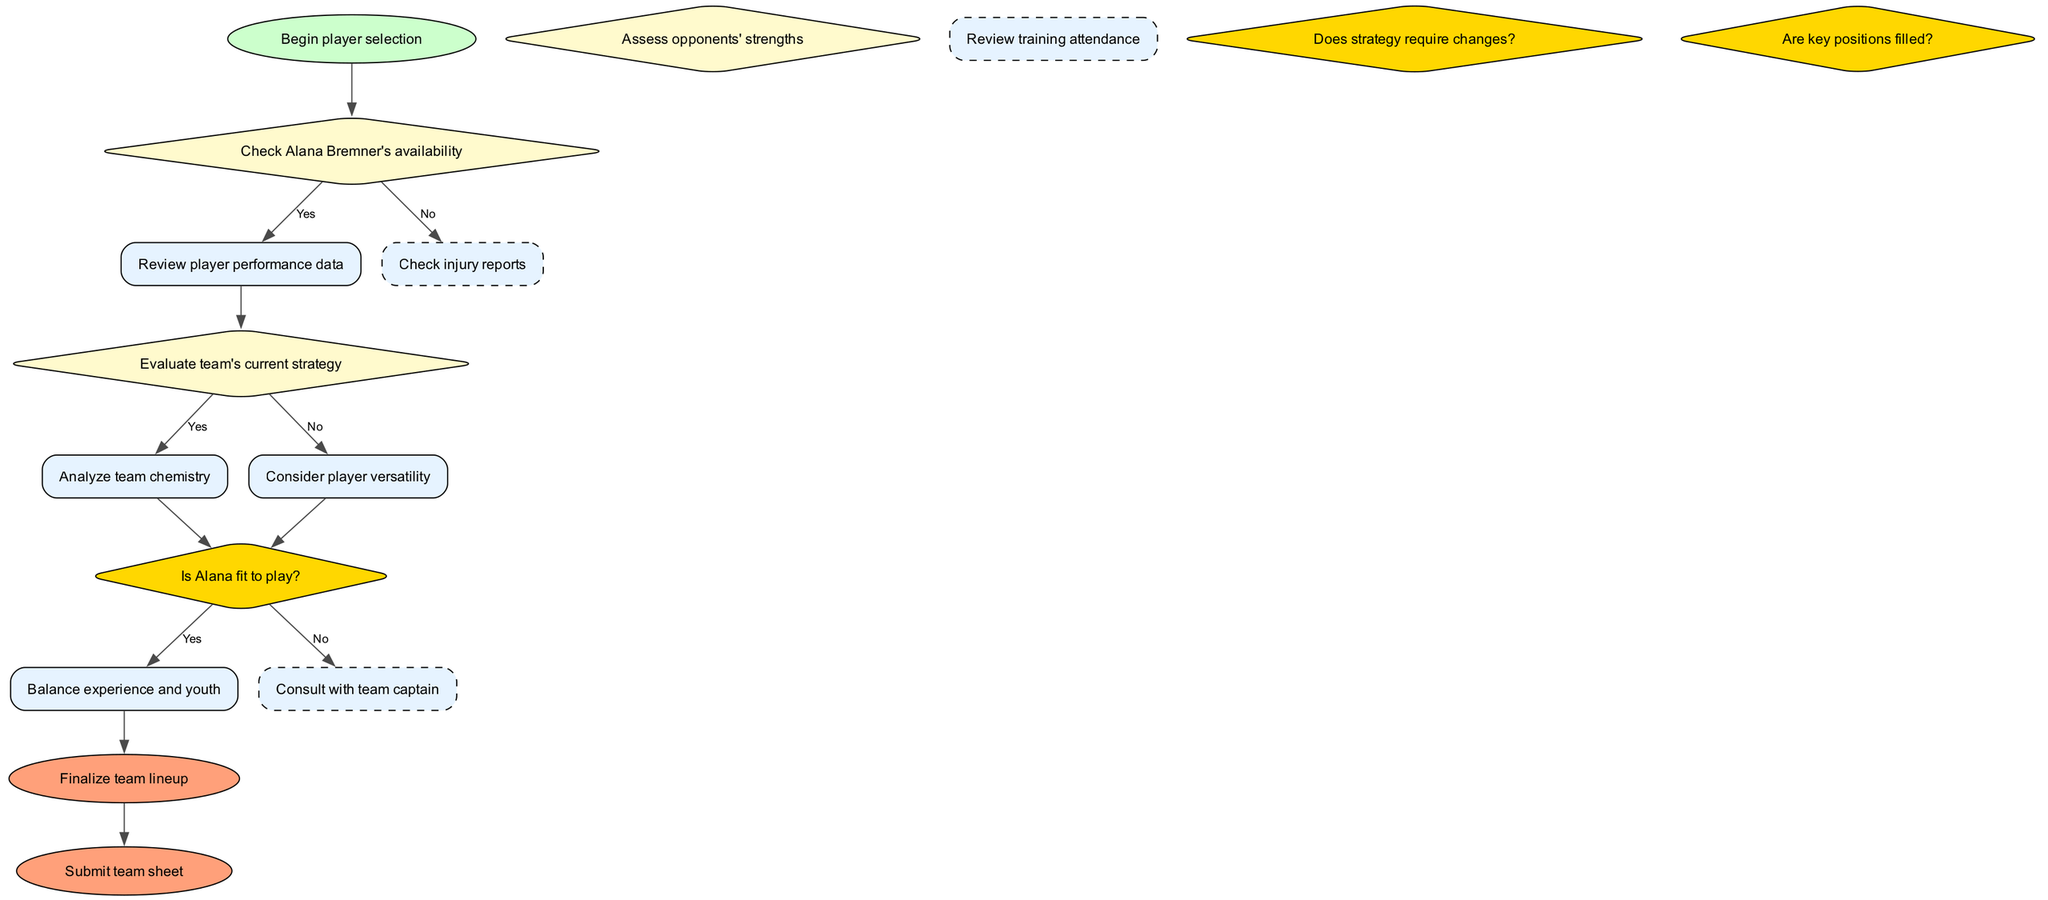What is the first step in the player selection algorithm? The first step is "Begin player selection," as indicated by the start node in the diagram.
Answer: Begin player selection How many decisions are made in the selection process? There are three decisions shown in the diagram, which are labeled sequentially as decision nodes.
Answer: 3 What happens if Alana Bremner is available? If Alana is available (fit to play), the flow proceeds to review player performance data, which is indicated by the edge labeled 'Yes' from the availability decision node.
Answer: Review player performance data If the strategy does not require changes, what is the subsequent action? If the strategy does not require changes, the flow directs toward considering player versatility, as indicated by the edge labeled 'No' from the strategy decision node.
Answer: Consider player versatility What type of node is used for assessing opponents' strengths? Assessing opponents' strengths is presented as a decision node, which typically has a diamond shape according to the diagram conventions.
Answer: Decision node What are the final steps in the algorithm? The final steps are "Finalize team lineup" followed by "Submit team sheet," represented as end nodes in the flowchart.
Answer: Finalize team lineup, Submit team sheet What does the algorithm do if Alana is not fit? If Alana is not fit, the flowchart indicates that it checks injury reports as the next action in the subprocess series, linking from her availability decision node.
Answer: Check injury reports What is the purpose of consulting with the team captain? Consulting with the team captain is part of the subprocesses that contributes to the decision-making process, ensuring player selection aligns with team dynamics and leadership input.
Answer: Ensure team dynamics If a key position is not filled, what is the next decision to make? The flow indicates that if a key position is not filled, further evaluations are likely needed, but the specific next step isn't explicitly described in this segment of the flowchart. Thus, additional team dynamics would need to be calculated.
Answer: Further evaluation How many end nodes are present in the flowchart? The diagram consists of two end nodes, representing the conclusion of the player selection process.
Answer: 2 